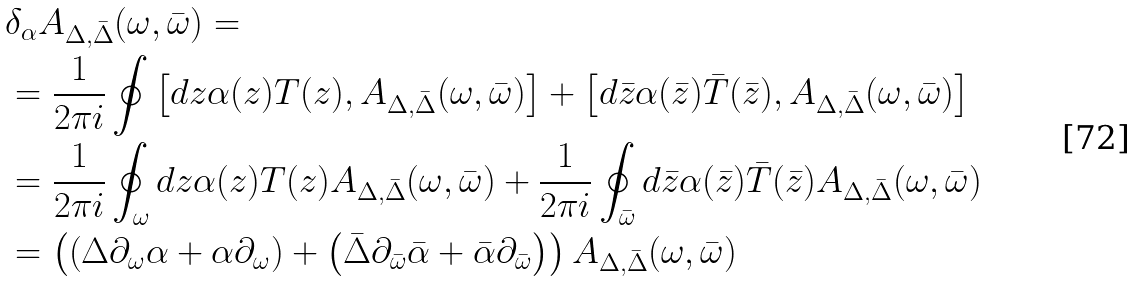<formula> <loc_0><loc_0><loc_500><loc_500>& \delta _ { \alpha } A _ { \Delta , \bar { \Delta } } ( \omega , \bar { \omega } ) = \\ & = \frac { 1 } { 2 \pi i } \oint \left [ d z \alpha ( z ) T ( z ) , A _ { \Delta , \bar { \Delta } } ( \omega , \bar { \omega } ) \right ] + \left [ d \bar { z } \alpha ( \bar { z } ) \bar { T } ( \bar { z } ) , A _ { \Delta , \bar { \Delta } } ( \omega , \bar { \omega } ) \right ] \\ & = \frac { 1 } { 2 \pi i } \oint _ { \omega } d z \alpha ( z ) T ( z ) A _ { \Delta , \bar { \Delta } } ( \omega , \bar { \omega } ) + \frac { 1 } { 2 \pi i } \oint _ { \bar { \omega } } d \bar { z } \alpha ( \bar { z } ) \bar { T } ( \bar { z } ) A _ { \Delta , \bar { \Delta } } ( \omega , \bar { \omega } ) \\ & = \left ( \left ( \Delta \partial _ { \omega } \alpha + \alpha \partial _ { \omega } \right ) + \left ( \bar { \Delta } \partial _ { \bar { \omega } } \bar { \alpha } + \bar { \alpha } \partial _ { \bar { \omega } } \right ) \right ) A _ { \Delta , \bar { \Delta } } ( \omega , \bar { \omega } )</formula> 